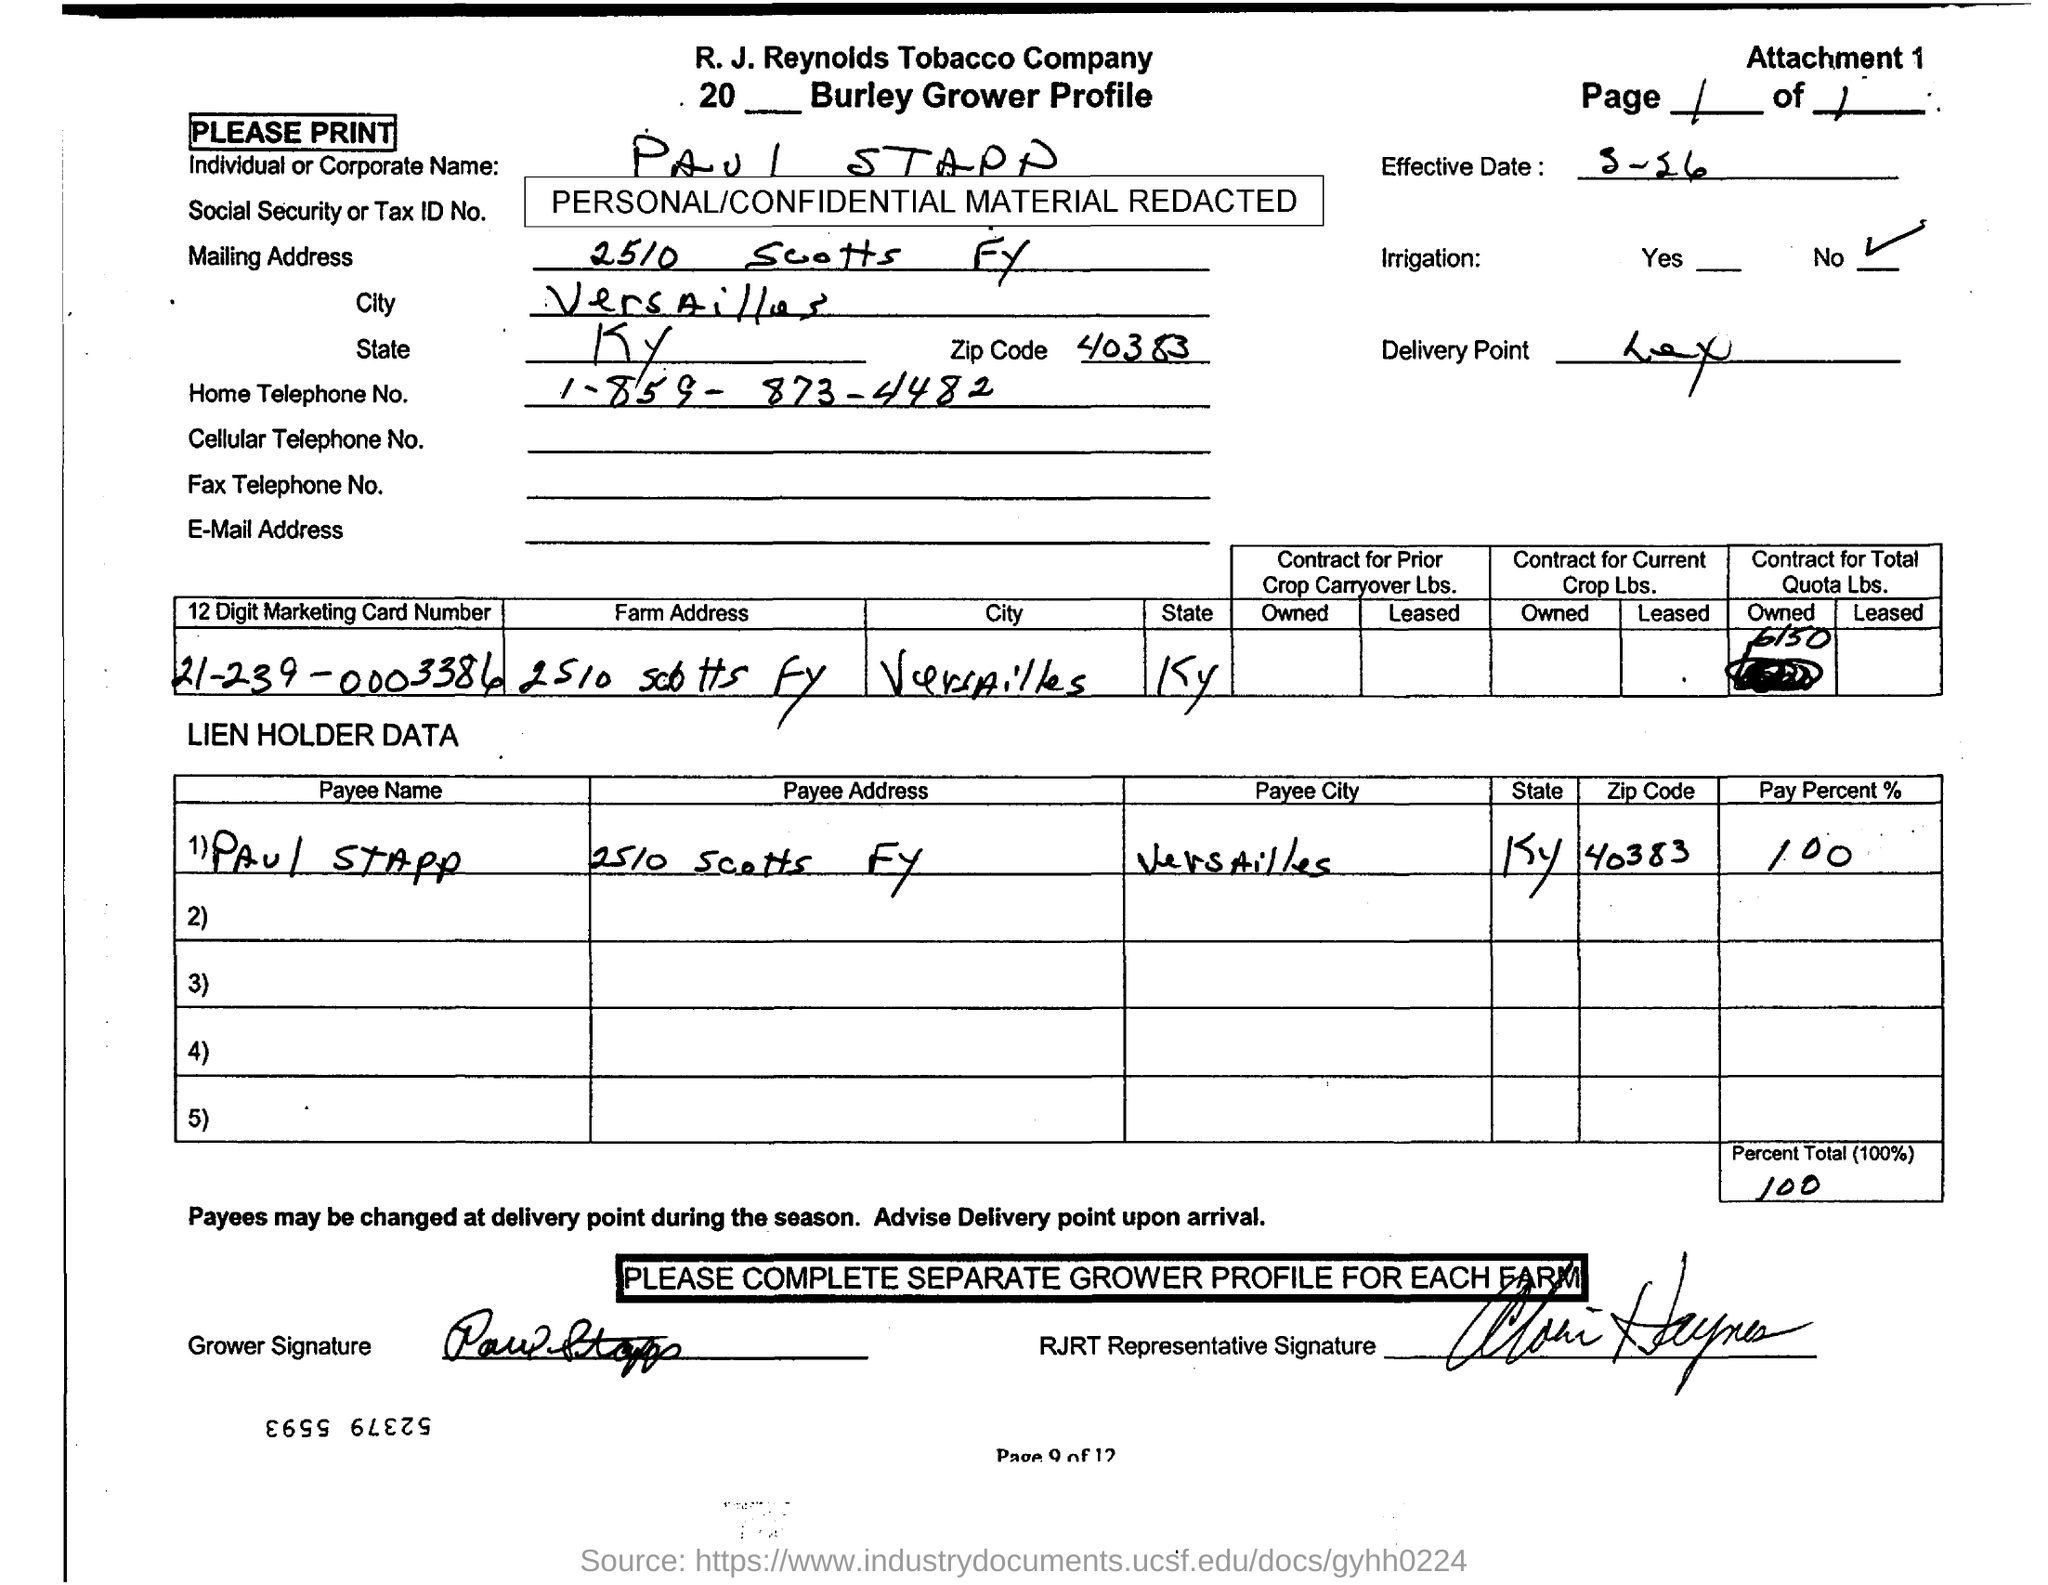What is the payee name mentioned in the document?
Offer a very short reply. Paul Stapp. What is the payee address mentioned in the document?
Your answer should be very brief. 2510 Scotts FY. What is the home telephone no of Paul Stapp?
Give a very brief answer. 1-859- 873-4482. What is the pay percent given in the document?
Provide a succinct answer. 100. What is the zipcode mentioned in this document?
Offer a very short reply. 40383. 